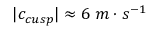<formula> <loc_0><loc_0><loc_500><loc_500>| c _ { c u s p } | \approx 6 \, m \cdot s ^ { - 1 }</formula> 